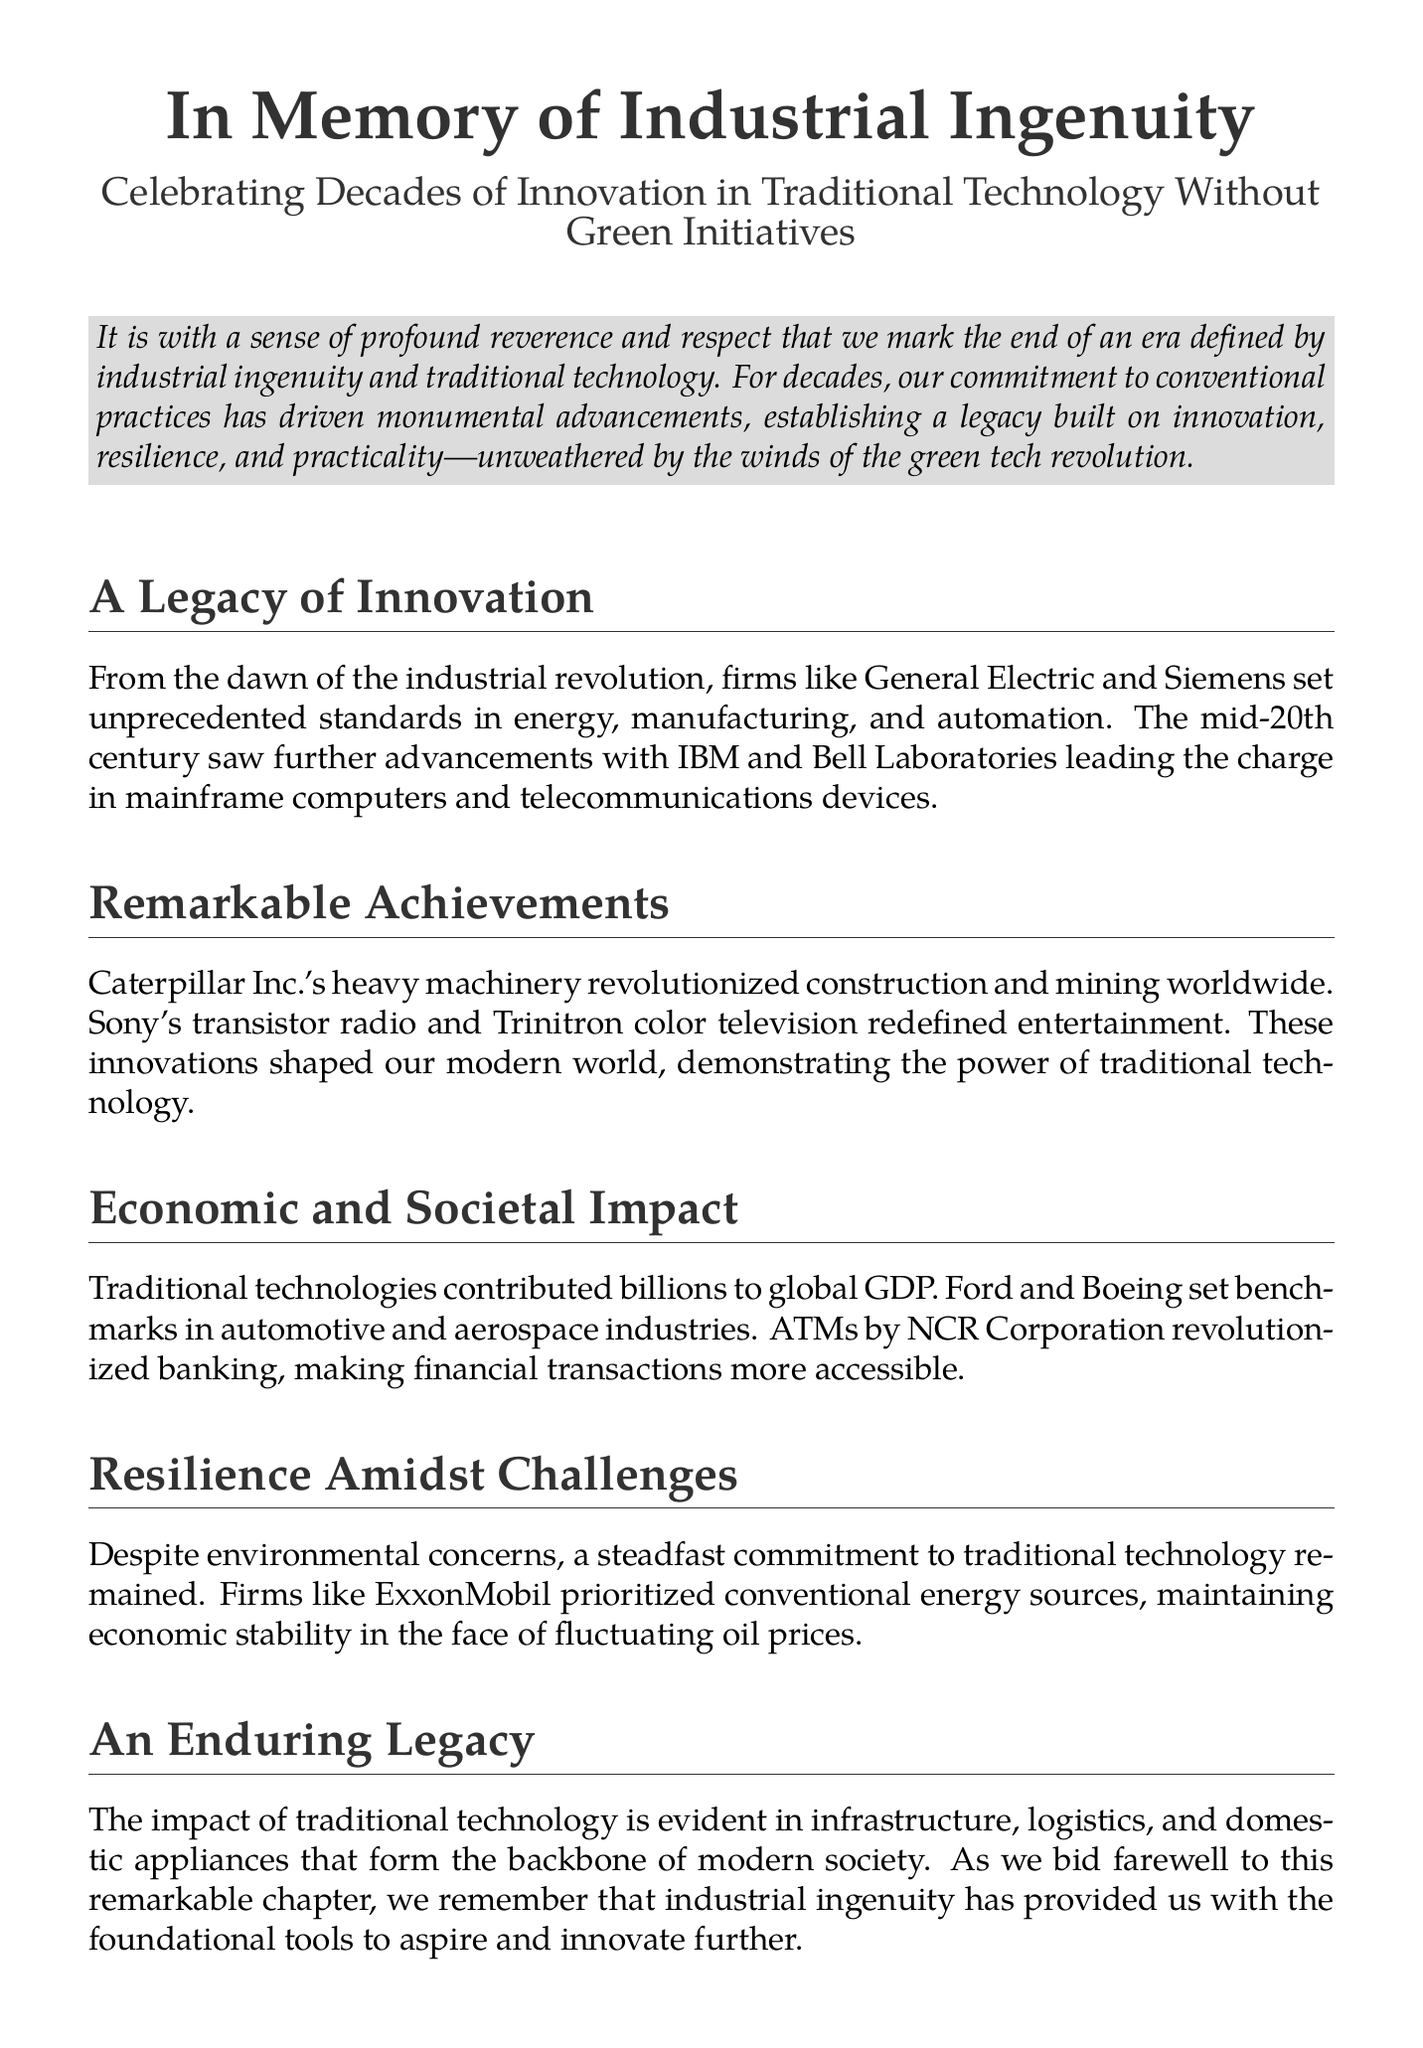What era is being marked in the document? The document commemorates an era defined by industrial ingenuity and traditional technology.
Answer: industrial ingenuity Which companies are mentioned as leaders in the industrial revolution? The document references firms like General Electric and Siemens as unprecedented standards in the industrial revolution.
Answer: General Electric and Siemens What type of achievements does Caterpillar Inc. represent? The document states that Caterpillar Inc.'s heavy machinery revolutionized construction and mining worldwide.
Answer: heavy machinery How did traditional technologies impact global GDP? The document mentions that traditional technologies contributed billions to global GDP.
Answer: billions What banking innovation is highlighted in the document? The document refers to ATMs by NCR Corporation as a revolution in banking making financial transactions more accessible.
Answer: ATMs Why did firms like ExxonMobil prioritize conventional energy? The document explains their commitment to traditional technology maintained economic stability in the face of fluctuating oil prices.
Answer: economic stability What is the overarching theme of the tribute? The document emphasizes the immense contributions of traditional technological advancements despite not venturing into green tech.
Answer: immense contributions How does the document conclude about industrial ingenuity? The conclusion underscores the enduring spirit of invention and resilience provided by industrial ingenuity.
Answer: enduring spirit of invention and resilience 